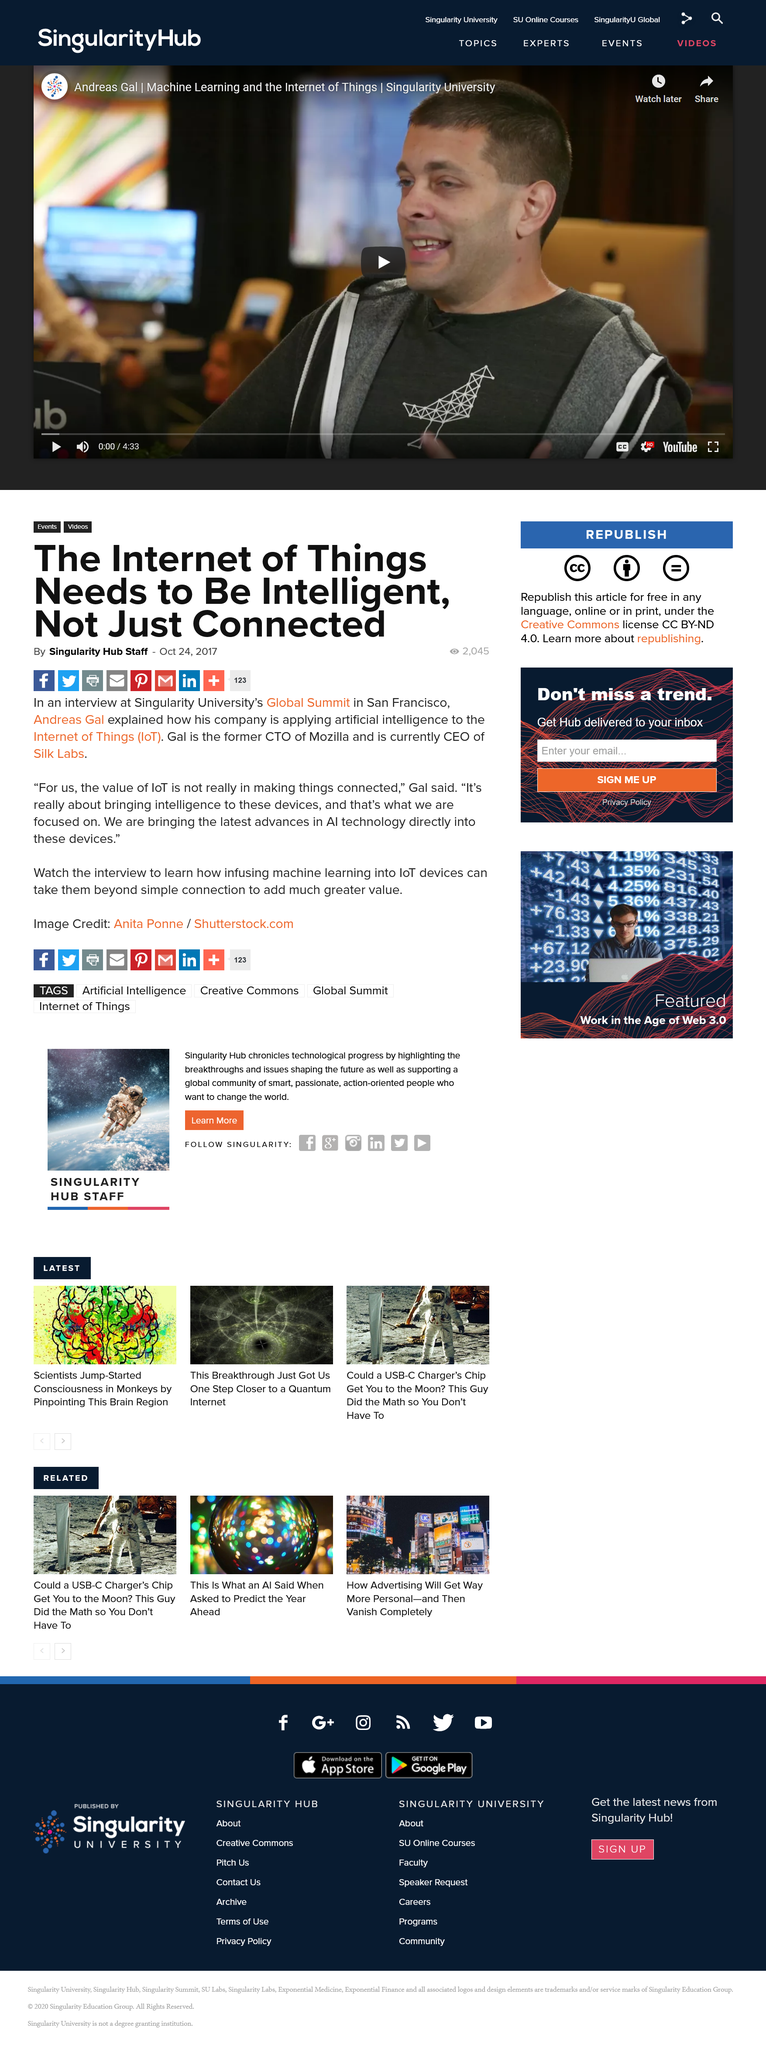Specify some key components in this picture. Andreas Gal is the CEO of Silk Labs. Andrew Gal is pursuing the application of artificial intelligence to the Internet of Things (IoT) in order to enhance the functionality and capabilities of the technology. Andrew Gal was interviewed at the Singularity University's Global Summit in San Francisco. 